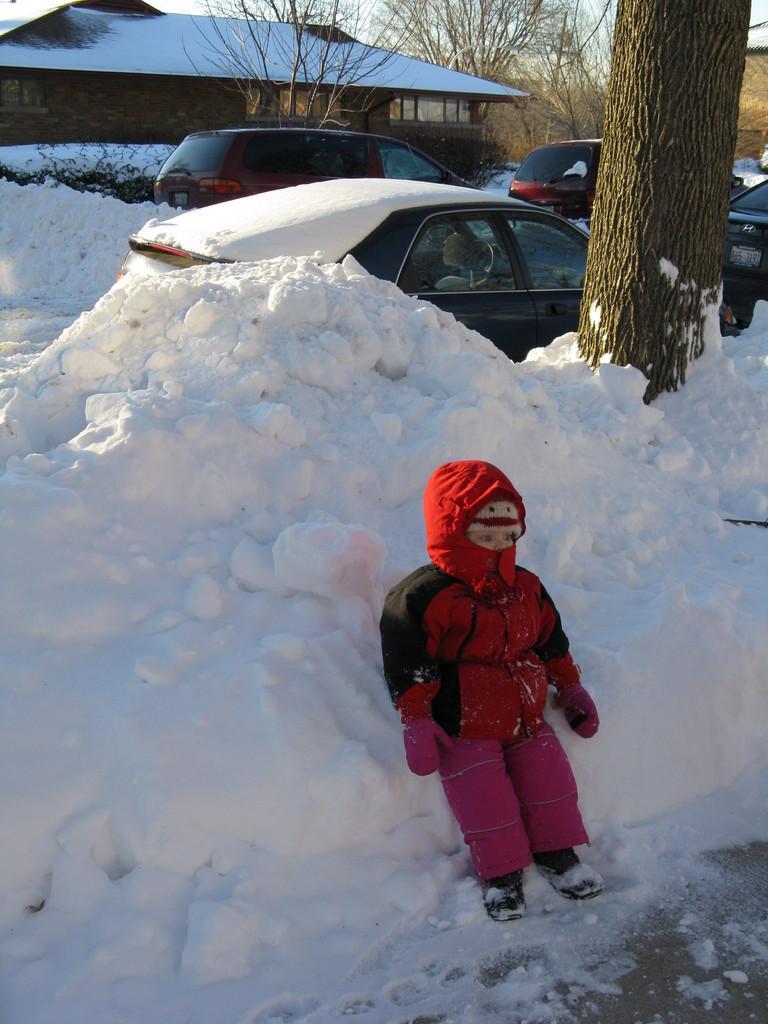Describe this image in one or two sentences. In this image we can see a child standing beside the heap of snow. On the backside we can see the bark of a tree, a group of cars, a house with roof and windows, a group of trees and the sky. 